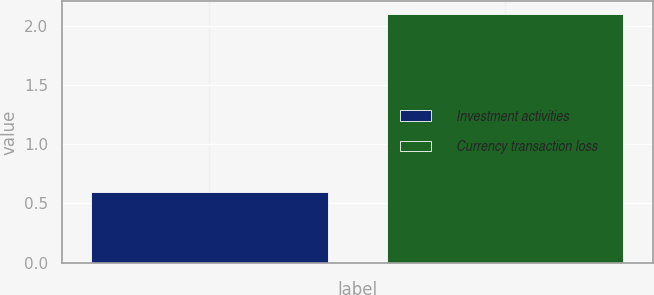<chart> <loc_0><loc_0><loc_500><loc_500><bar_chart><fcel>Investment activities<fcel>Currency transaction loss<nl><fcel>0.6<fcel>2.1<nl></chart> 